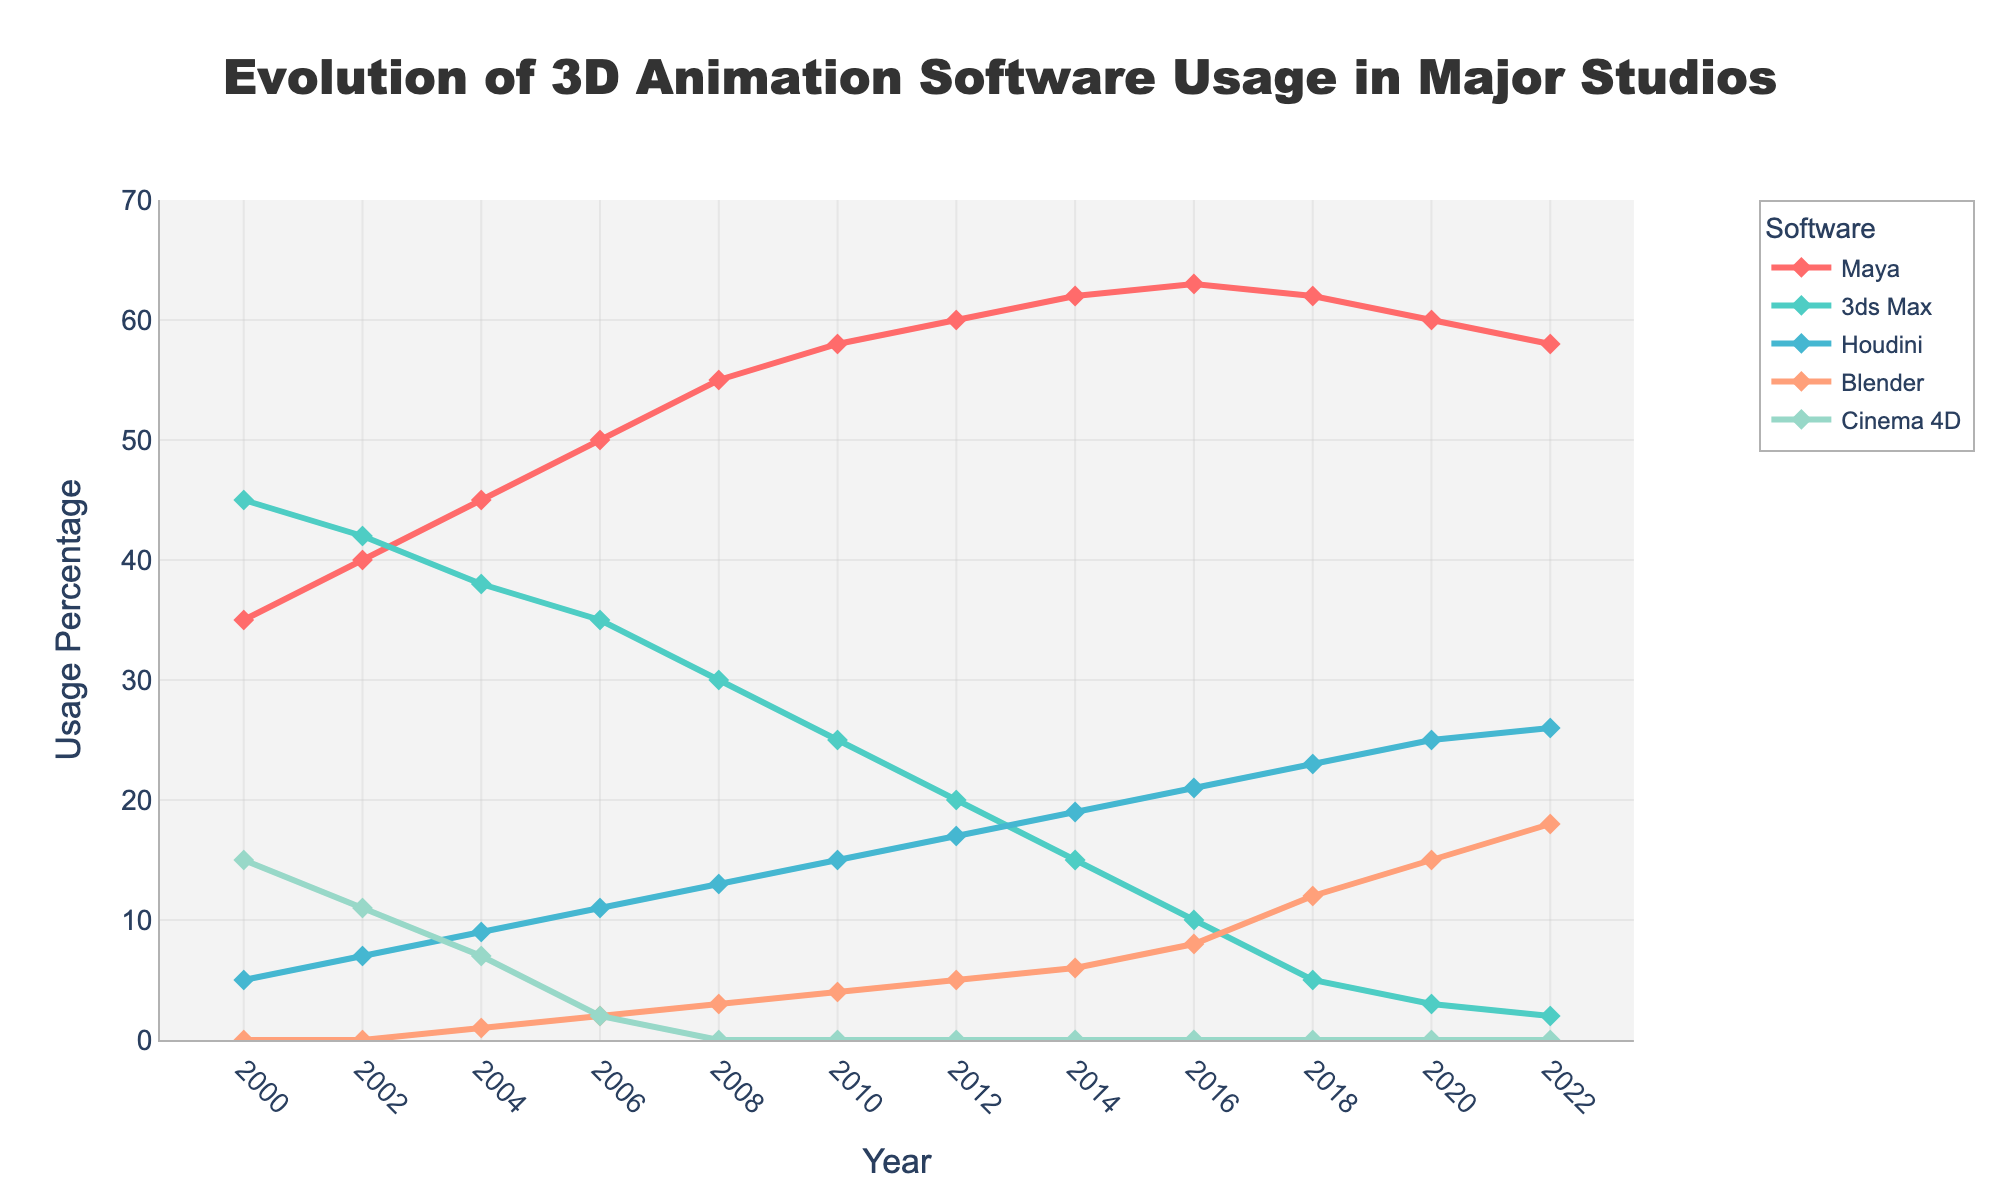What is the trend of Blender usage from 2000 to 2022? The usage of Blender has shown a consistent increase from 0% in 2000 to 18% in 2022. This trend suggests that Blender's adoption has grown steadily over the last two decades.
Answer: Increasing trend Which software had the highest usage in the year 2000? By comparing the usage percentages in 2000, 3ds Max had the highest usage rate at 45%, followed by Maya at 35%, Cinema 4D at 15%, and Houdini at 5%, while Blender had 0%.
Answer: 3ds Max Between Maya and 3ds Max, which had a larger decrease in usage from 2000 to 2022? Maya's usage decreased from 35% in 2000 to 58% in 2022, which is a decrease of 42%. 3ds Max's usage decreased from 45% in 2000 to 2% in 2022, which is a decrease of 43%.
Answer: 3ds Max What is the combined usage of Houdini and Blender in 2018? In 2018, Houdini had a usage of 23%, and Blender had a usage of 12%. Summing these gives 23% + 12% = 35%.
Answer: 35% In which year did Cinema 4D usage drop to 0%? Looking at the Cinema 4D usage data, it dropped to 0% in 2008 and has stayed consistent at 0% since then.
Answer: 2008 How did the usage of 3ds Max change from 2000 to 2010? In 2000, 3ds Max usage was 45%. By 2010, it had decreased to 25%. This shows a decrease of 45% - 25% = 20% over the ten-year period.
Answer: Decreased by 20% Compare the percentage usage of Maya and Houdini in 2022. Which was higher and by how much? In 2022, Maya had a usage of 58%, while Houdini had a usage of 26%. Maya's usage was higher by 58% - 26% = 32%.
Answer: Maya by 32% Which software showed a continuous increase in usage over the entire period 2000 to 2022? From the trends visible in the chart, both Houdini and Blender showed continuous increases in their usage percentages over the two-decade period.
Answer: Houdini and Blender What was the difference in Maya usage between the years 2000 and 2006? Maya usage was 35% in 2000 and increased to 50% by 2006. The difference is 50% - 35% = 15%.
Answer: 15% 